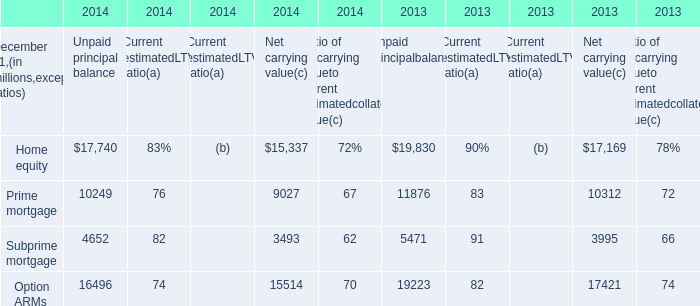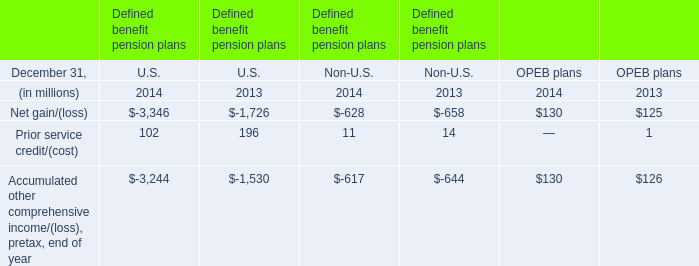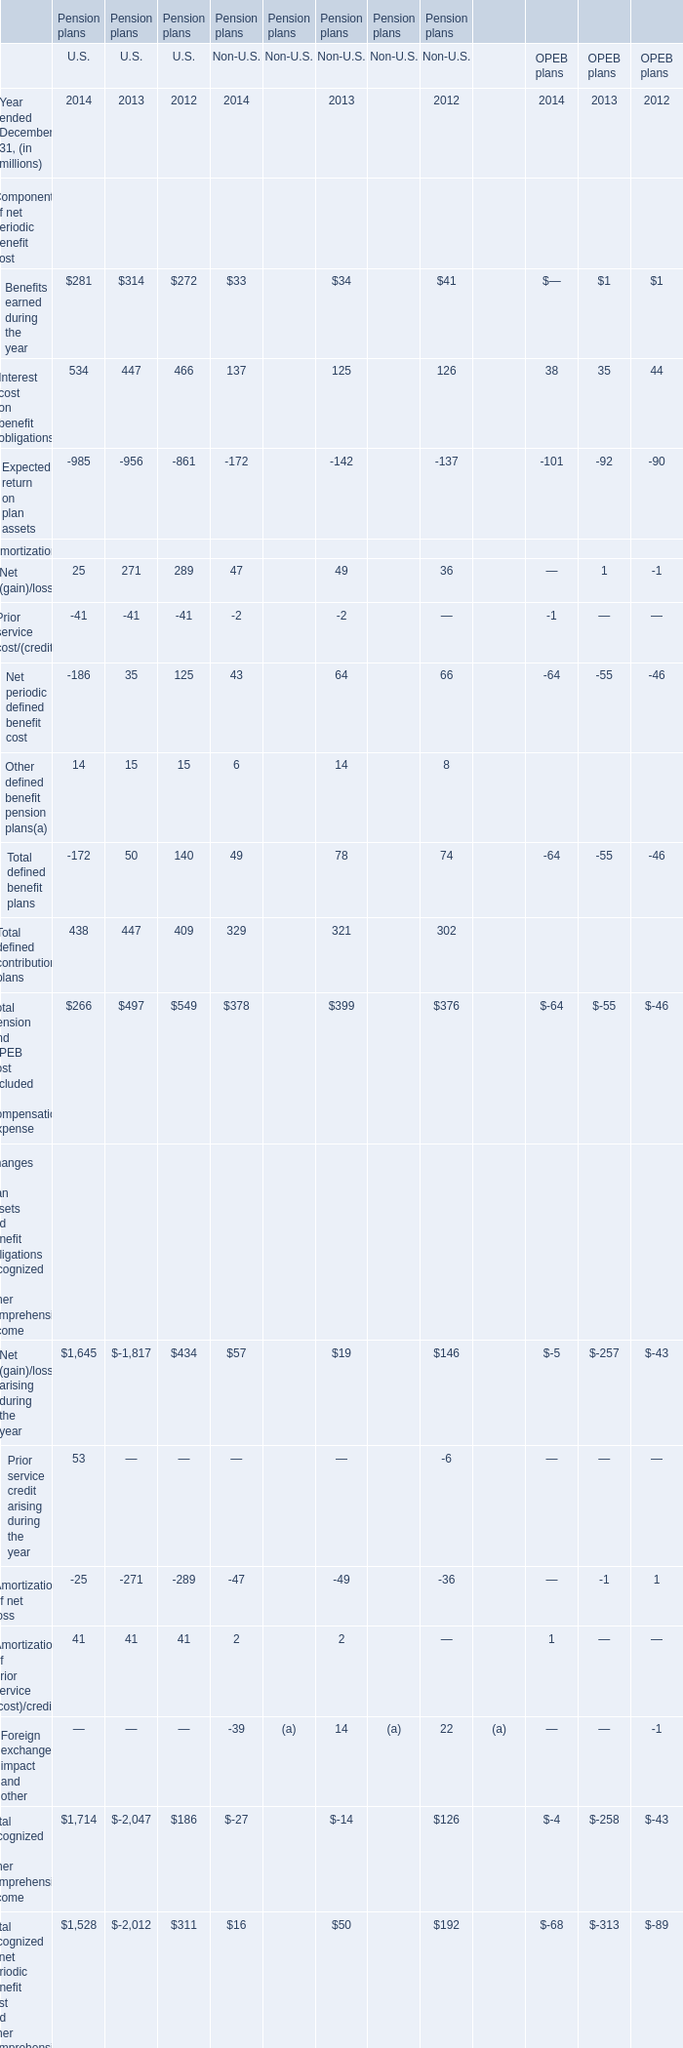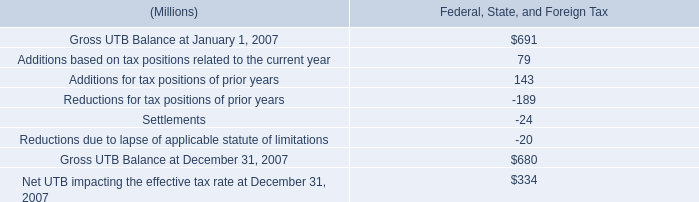at january 12007 what was the percent of the interest and penalties included in the gross unrecognized tax benefits 
Computations: ((65 + 69) / 691)
Answer: 0.19392. 